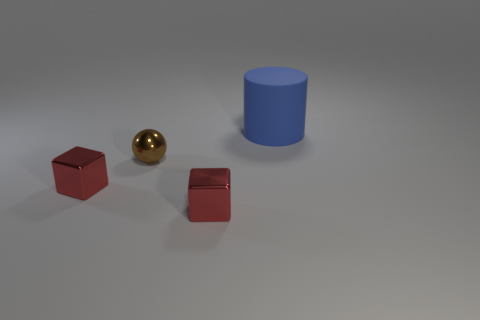Add 3 large blue things. How many objects exist? 7 Subtract all cylinders. How many objects are left? 3 Add 2 matte cylinders. How many matte cylinders exist? 3 Subtract 0 purple cylinders. How many objects are left? 4 Subtract all green blocks. Subtract all green balls. How many blocks are left? 2 Subtract all red shiny cubes. Subtract all red metal cubes. How many objects are left? 0 Add 3 blue cylinders. How many blue cylinders are left? 4 